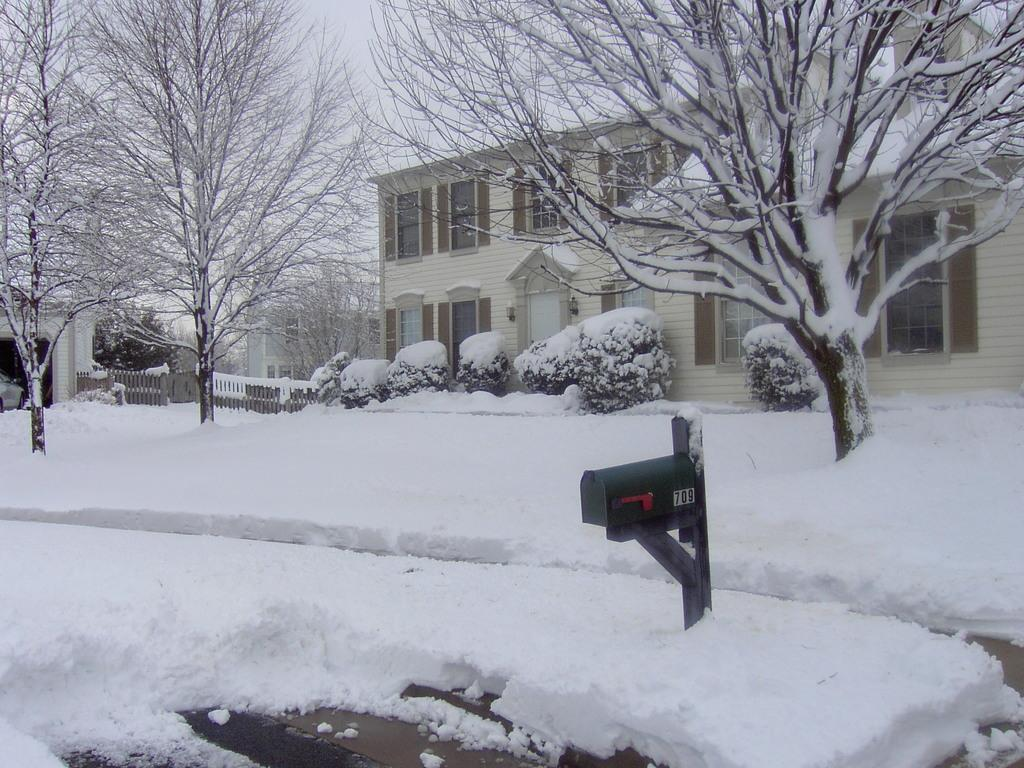What type of terrain is visible in the image? Ground is visible in the image. What type of vegetation can be seen in the image? There are trees and plants covered with snow in the image. What is the object on the ground in the image? The object on the ground in the image is not specified, but it could be a snowman or a snow sculpture. What architectural features can be seen in the image? There are buildings with windows in the image, and there is a door visible on a building. What is visible in the sky in the image? The sky is visible in the image, but the weather or time of day is not specified. How many kites are being flown by the self in the image? There are no kites or people visible in the image, so it is not possible to answer this question. 